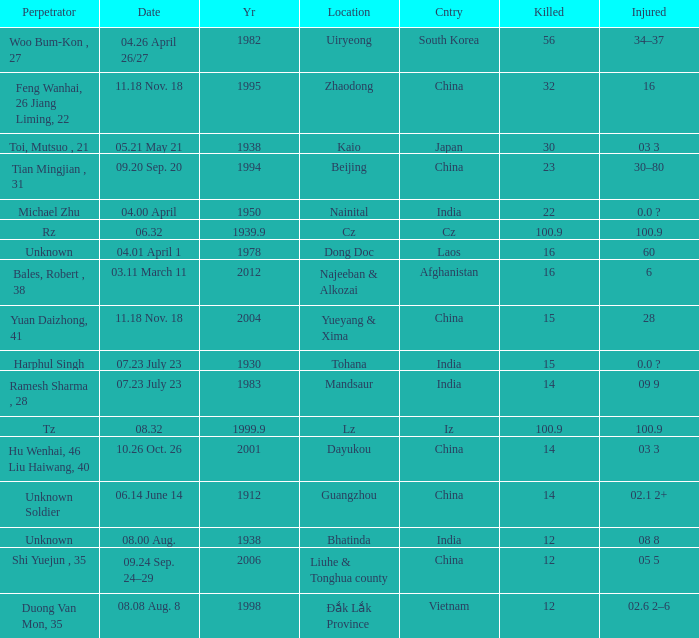What is Country, when Killed is "100.9", and when Year is greater than 1939.9? Iz. 